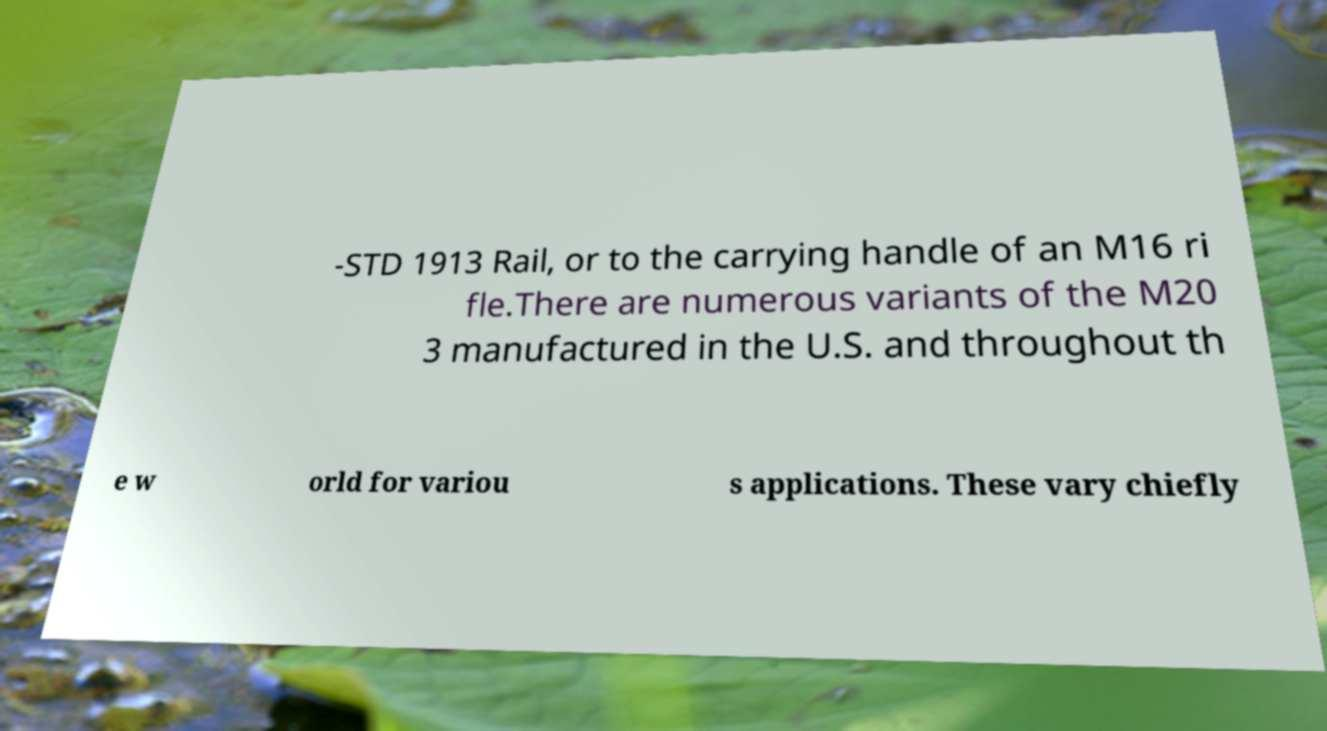Can you read and provide the text displayed in the image?This photo seems to have some interesting text. Can you extract and type it out for me? -STD 1913 Rail, or to the carrying handle of an M16 ri fle.There are numerous variants of the M20 3 manufactured in the U.S. and throughout th e w orld for variou s applications. These vary chiefly 